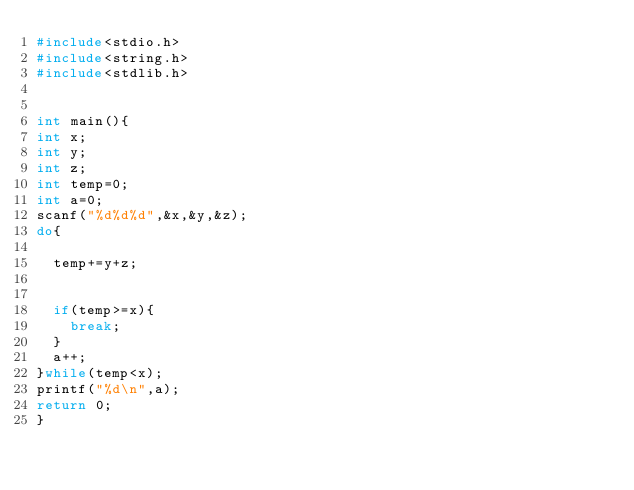Convert code to text. <code><loc_0><loc_0><loc_500><loc_500><_C_>#include<stdio.h>
#include<string.h>
#include<stdlib.h>
 
 
int main(){
int x;
int y;
int z;
int temp=0;
int a=0;
scanf("%d%d%d",&x,&y,&z);
do{
	
	temp+=y+z;
	
	
	if(temp>=x){
		break;
	}
	a++;
}while(temp<x);
printf("%d\n",a);
return 0;
}
</code> 